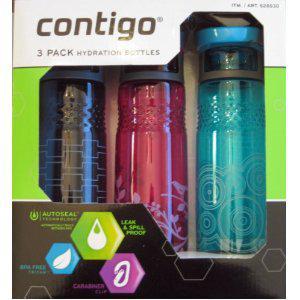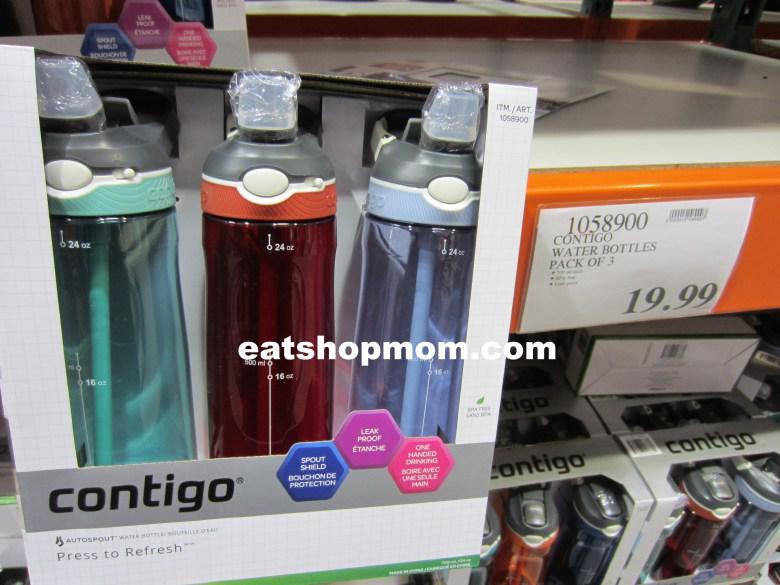The first image is the image on the left, the second image is the image on the right. Given the left and right images, does the statement "A stainless steel water bottle is next to a green water bottle." hold true? Answer yes or no. No. The first image is the image on the left, the second image is the image on the right. For the images displayed, is the sentence "A package showing three different colors of water bottles features a trio of blue, violet and hot pink hexagon shapes on the bottom front of the box." factually correct? Answer yes or no. Yes. 